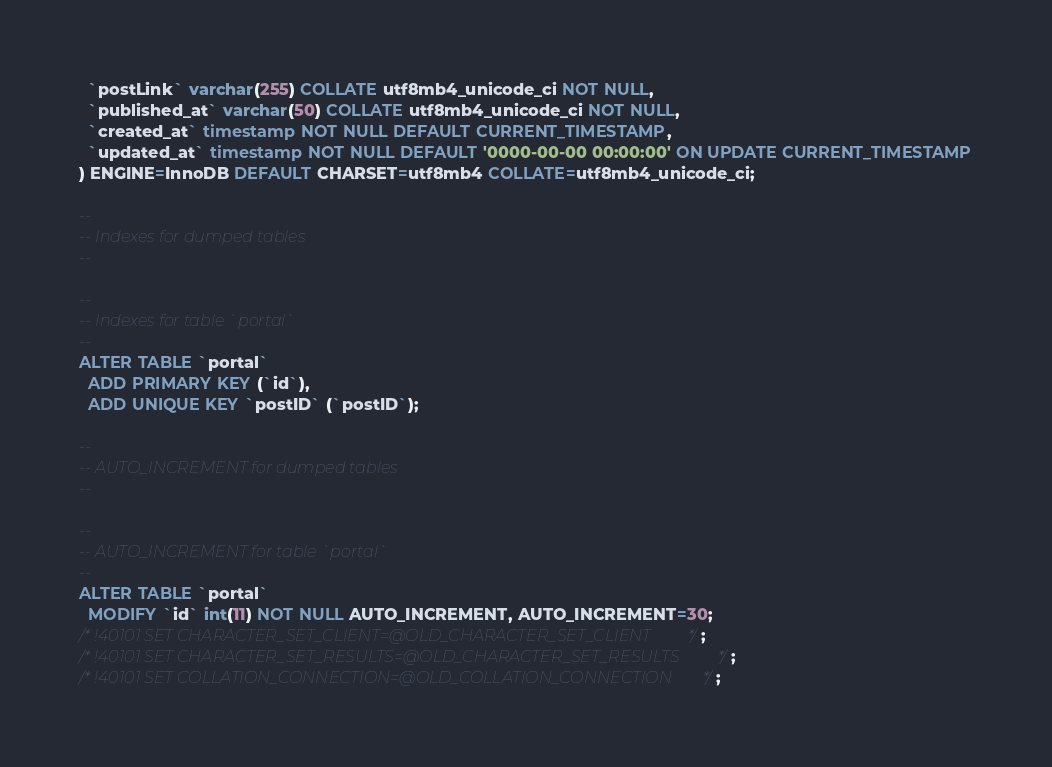Convert code to text. <code><loc_0><loc_0><loc_500><loc_500><_SQL_>  `postLink` varchar(255) COLLATE utf8mb4_unicode_ci NOT NULL,
  `published_at` varchar(50) COLLATE utf8mb4_unicode_ci NOT NULL,
  `created_at` timestamp NOT NULL DEFAULT CURRENT_TIMESTAMP,
  `updated_at` timestamp NOT NULL DEFAULT '0000-00-00 00:00:00' ON UPDATE CURRENT_TIMESTAMP
) ENGINE=InnoDB DEFAULT CHARSET=utf8mb4 COLLATE=utf8mb4_unicode_ci;

--
-- Indexes for dumped tables
--

--
-- Indexes for table `portal`
--
ALTER TABLE `portal`
  ADD PRIMARY KEY (`id`),
  ADD UNIQUE KEY `postID` (`postID`);

--
-- AUTO_INCREMENT for dumped tables
--

--
-- AUTO_INCREMENT for table `portal`
--
ALTER TABLE `portal`
  MODIFY `id` int(11) NOT NULL AUTO_INCREMENT, AUTO_INCREMENT=30;
/*!40101 SET CHARACTER_SET_CLIENT=@OLD_CHARACTER_SET_CLIENT */;
/*!40101 SET CHARACTER_SET_RESULTS=@OLD_CHARACTER_SET_RESULTS */;
/*!40101 SET COLLATION_CONNECTION=@OLD_COLLATION_CONNECTION */;
</code> 